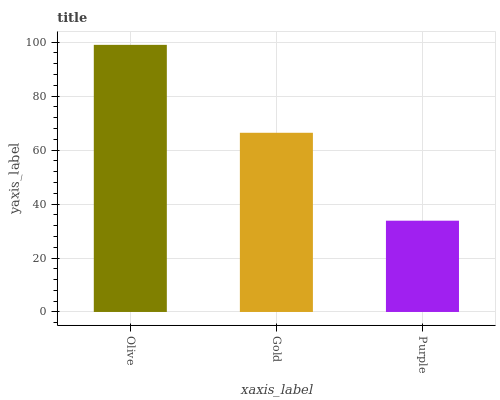Is Purple the minimum?
Answer yes or no. Yes. Is Olive the maximum?
Answer yes or no. Yes. Is Gold the minimum?
Answer yes or no. No. Is Gold the maximum?
Answer yes or no. No. Is Olive greater than Gold?
Answer yes or no. Yes. Is Gold less than Olive?
Answer yes or no. Yes. Is Gold greater than Olive?
Answer yes or no. No. Is Olive less than Gold?
Answer yes or no. No. Is Gold the high median?
Answer yes or no. Yes. Is Gold the low median?
Answer yes or no. Yes. Is Olive the high median?
Answer yes or no. No. Is Olive the low median?
Answer yes or no. No. 